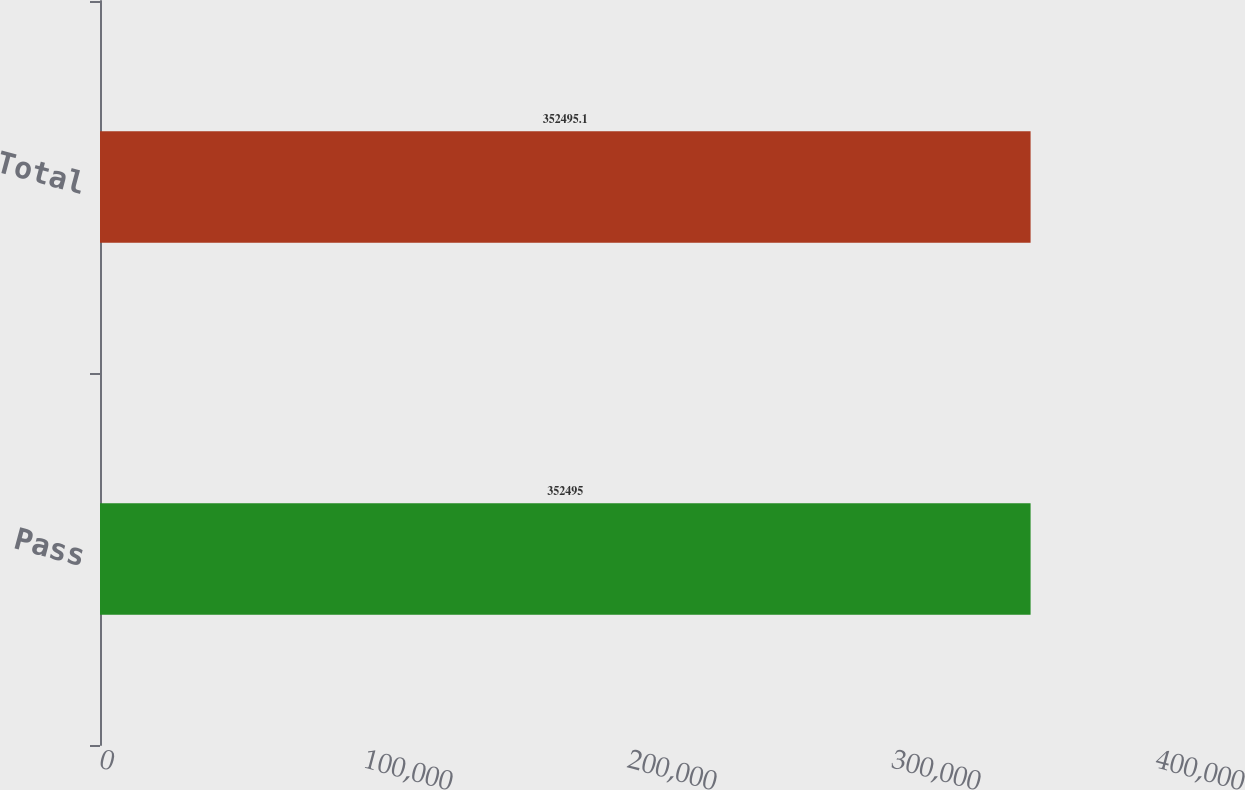<chart> <loc_0><loc_0><loc_500><loc_500><bar_chart><fcel>Pass<fcel>Total<nl><fcel>352495<fcel>352495<nl></chart> 